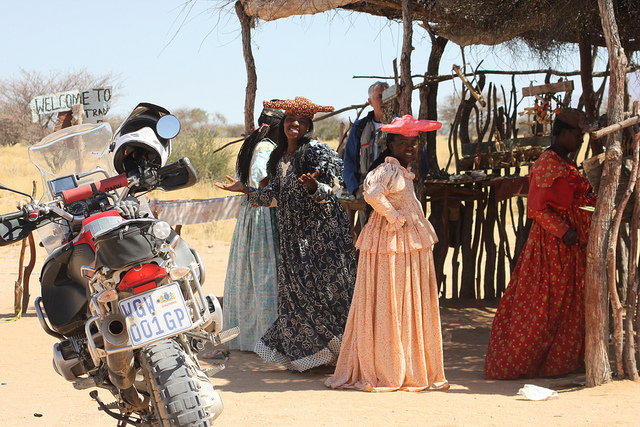Please extract the text content from this image. GP WELCOME TO 